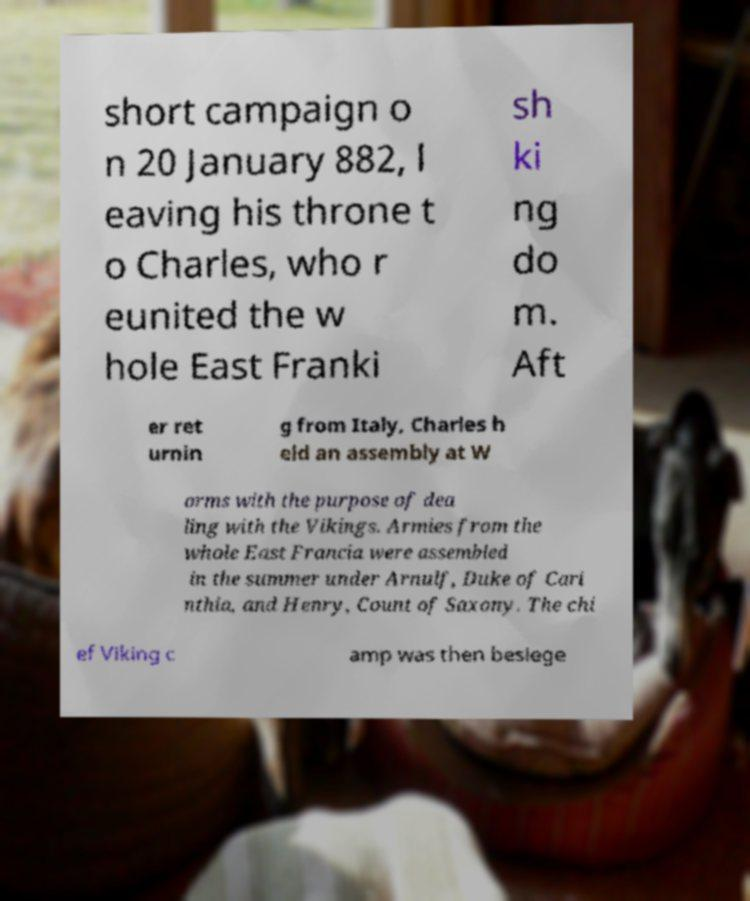Please read and relay the text visible in this image. What does it say? short campaign o n 20 January 882, l eaving his throne t o Charles, who r eunited the w hole East Franki sh ki ng do m. Aft er ret urnin g from Italy, Charles h eld an assembly at W orms with the purpose of dea ling with the Vikings. Armies from the whole East Francia were assembled in the summer under Arnulf, Duke of Cari nthia, and Henry, Count of Saxony. The chi ef Viking c amp was then besiege 